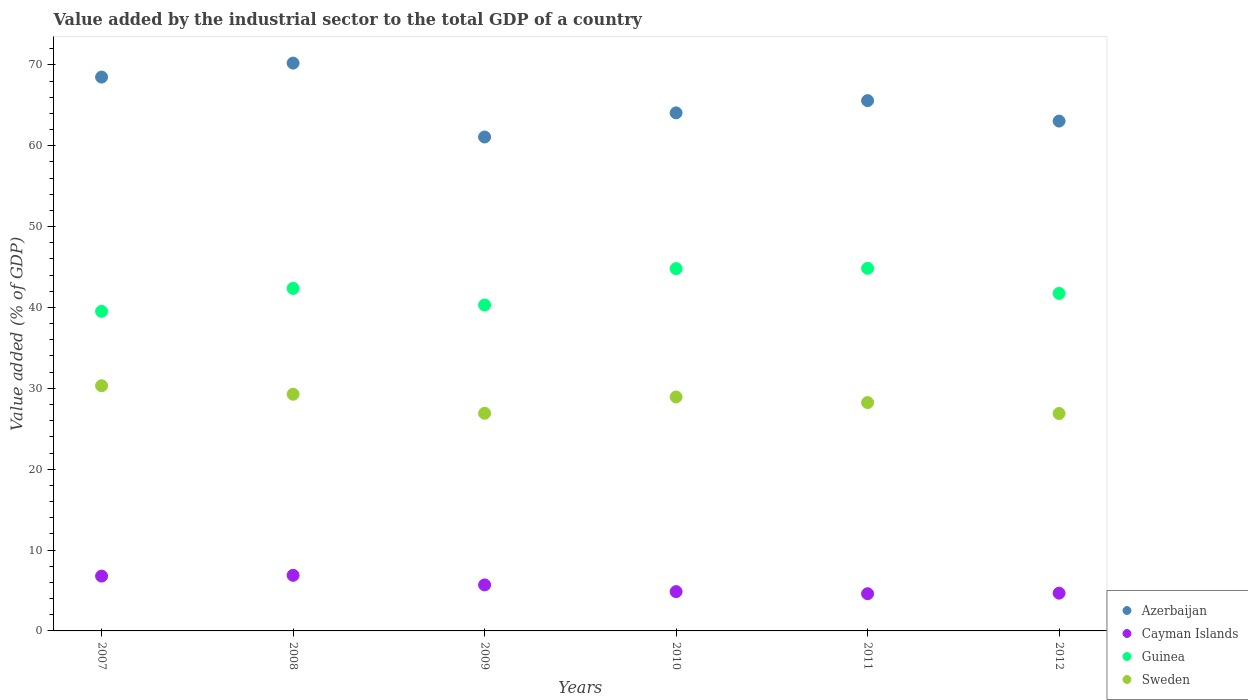How many different coloured dotlines are there?
Offer a terse response. 4. Is the number of dotlines equal to the number of legend labels?
Keep it short and to the point. Yes. What is the value added by the industrial sector to the total GDP in Azerbaijan in 2009?
Provide a succinct answer. 61.08. Across all years, what is the maximum value added by the industrial sector to the total GDP in Sweden?
Your response must be concise. 30.32. Across all years, what is the minimum value added by the industrial sector to the total GDP in Azerbaijan?
Give a very brief answer. 61.08. In which year was the value added by the industrial sector to the total GDP in Guinea minimum?
Give a very brief answer. 2007. What is the total value added by the industrial sector to the total GDP in Guinea in the graph?
Offer a very short reply. 253.57. What is the difference between the value added by the industrial sector to the total GDP in Sweden in 2009 and that in 2012?
Your answer should be very brief. 0.03. What is the difference between the value added by the industrial sector to the total GDP in Guinea in 2011 and the value added by the industrial sector to the total GDP in Cayman Islands in 2012?
Provide a short and direct response. 40.17. What is the average value added by the industrial sector to the total GDP in Azerbaijan per year?
Provide a short and direct response. 65.42. In the year 2008, what is the difference between the value added by the industrial sector to the total GDP in Cayman Islands and value added by the industrial sector to the total GDP in Sweden?
Your response must be concise. -22.4. In how many years, is the value added by the industrial sector to the total GDP in Cayman Islands greater than 64 %?
Ensure brevity in your answer.  0. What is the ratio of the value added by the industrial sector to the total GDP in Cayman Islands in 2008 to that in 2010?
Provide a short and direct response. 1.41. Is the value added by the industrial sector to the total GDP in Sweden in 2007 less than that in 2008?
Keep it short and to the point. No. Is the difference between the value added by the industrial sector to the total GDP in Cayman Islands in 2009 and 2010 greater than the difference between the value added by the industrial sector to the total GDP in Sweden in 2009 and 2010?
Provide a succinct answer. Yes. What is the difference between the highest and the second highest value added by the industrial sector to the total GDP in Sweden?
Give a very brief answer. 1.05. What is the difference between the highest and the lowest value added by the industrial sector to the total GDP in Azerbaijan?
Offer a terse response. 9.14. In how many years, is the value added by the industrial sector to the total GDP in Cayman Islands greater than the average value added by the industrial sector to the total GDP in Cayman Islands taken over all years?
Offer a very short reply. 3. Is the sum of the value added by the industrial sector to the total GDP in Guinea in 2007 and 2011 greater than the maximum value added by the industrial sector to the total GDP in Azerbaijan across all years?
Keep it short and to the point. Yes. Is it the case that in every year, the sum of the value added by the industrial sector to the total GDP in Azerbaijan and value added by the industrial sector to the total GDP in Cayman Islands  is greater than the sum of value added by the industrial sector to the total GDP in Sweden and value added by the industrial sector to the total GDP in Guinea?
Give a very brief answer. Yes. Does the value added by the industrial sector to the total GDP in Sweden monotonically increase over the years?
Your answer should be very brief. No. How many dotlines are there?
Provide a succinct answer. 4. How many years are there in the graph?
Your answer should be very brief. 6. What is the difference between two consecutive major ticks on the Y-axis?
Give a very brief answer. 10. Are the values on the major ticks of Y-axis written in scientific E-notation?
Make the answer very short. No. What is the title of the graph?
Your answer should be compact. Value added by the industrial sector to the total GDP of a country. What is the label or title of the X-axis?
Your response must be concise. Years. What is the label or title of the Y-axis?
Provide a short and direct response. Value added (% of GDP). What is the Value added (% of GDP) in Azerbaijan in 2007?
Offer a terse response. 68.49. What is the Value added (% of GDP) in Cayman Islands in 2007?
Keep it short and to the point. 6.78. What is the Value added (% of GDP) in Guinea in 2007?
Your answer should be very brief. 39.52. What is the Value added (% of GDP) in Sweden in 2007?
Give a very brief answer. 30.32. What is the Value added (% of GDP) in Azerbaijan in 2008?
Ensure brevity in your answer.  70.22. What is the Value added (% of GDP) in Cayman Islands in 2008?
Your answer should be compact. 6.87. What is the Value added (% of GDP) of Guinea in 2008?
Your answer should be very brief. 42.36. What is the Value added (% of GDP) of Sweden in 2008?
Ensure brevity in your answer.  29.27. What is the Value added (% of GDP) in Azerbaijan in 2009?
Ensure brevity in your answer.  61.08. What is the Value added (% of GDP) of Cayman Islands in 2009?
Provide a succinct answer. 5.69. What is the Value added (% of GDP) in Guinea in 2009?
Offer a very short reply. 40.31. What is the Value added (% of GDP) in Sweden in 2009?
Keep it short and to the point. 26.92. What is the Value added (% of GDP) in Azerbaijan in 2010?
Offer a terse response. 64.07. What is the Value added (% of GDP) in Cayman Islands in 2010?
Keep it short and to the point. 4.86. What is the Value added (% of GDP) of Guinea in 2010?
Offer a terse response. 44.8. What is the Value added (% of GDP) in Sweden in 2010?
Give a very brief answer. 28.93. What is the Value added (% of GDP) in Azerbaijan in 2011?
Make the answer very short. 65.58. What is the Value added (% of GDP) of Cayman Islands in 2011?
Your answer should be very brief. 4.6. What is the Value added (% of GDP) in Guinea in 2011?
Your answer should be compact. 44.84. What is the Value added (% of GDP) in Sweden in 2011?
Provide a succinct answer. 28.24. What is the Value added (% of GDP) in Azerbaijan in 2012?
Ensure brevity in your answer.  63.05. What is the Value added (% of GDP) of Cayman Islands in 2012?
Give a very brief answer. 4.67. What is the Value added (% of GDP) in Guinea in 2012?
Give a very brief answer. 41.74. What is the Value added (% of GDP) of Sweden in 2012?
Make the answer very short. 26.89. Across all years, what is the maximum Value added (% of GDP) in Azerbaijan?
Give a very brief answer. 70.22. Across all years, what is the maximum Value added (% of GDP) in Cayman Islands?
Make the answer very short. 6.87. Across all years, what is the maximum Value added (% of GDP) of Guinea?
Offer a very short reply. 44.84. Across all years, what is the maximum Value added (% of GDP) of Sweden?
Keep it short and to the point. 30.32. Across all years, what is the minimum Value added (% of GDP) of Azerbaijan?
Your answer should be compact. 61.08. Across all years, what is the minimum Value added (% of GDP) in Cayman Islands?
Your response must be concise. 4.6. Across all years, what is the minimum Value added (% of GDP) of Guinea?
Ensure brevity in your answer.  39.52. Across all years, what is the minimum Value added (% of GDP) of Sweden?
Give a very brief answer. 26.89. What is the total Value added (% of GDP) of Azerbaijan in the graph?
Make the answer very short. 392.5. What is the total Value added (% of GDP) of Cayman Islands in the graph?
Your response must be concise. 33.47. What is the total Value added (% of GDP) of Guinea in the graph?
Your answer should be compact. 253.57. What is the total Value added (% of GDP) in Sweden in the graph?
Provide a short and direct response. 170.56. What is the difference between the Value added (% of GDP) of Azerbaijan in 2007 and that in 2008?
Your answer should be very brief. -1.73. What is the difference between the Value added (% of GDP) of Cayman Islands in 2007 and that in 2008?
Provide a short and direct response. -0.09. What is the difference between the Value added (% of GDP) in Guinea in 2007 and that in 2008?
Keep it short and to the point. -2.84. What is the difference between the Value added (% of GDP) of Sweden in 2007 and that in 2008?
Keep it short and to the point. 1.05. What is the difference between the Value added (% of GDP) of Azerbaijan in 2007 and that in 2009?
Offer a very short reply. 7.41. What is the difference between the Value added (% of GDP) of Cayman Islands in 2007 and that in 2009?
Your answer should be very brief. 1.09. What is the difference between the Value added (% of GDP) of Guinea in 2007 and that in 2009?
Give a very brief answer. -0.78. What is the difference between the Value added (% of GDP) in Sweden in 2007 and that in 2009?
Your answer should be very brief. 3.4. What is the difference between the Value added (% of GDP) in Azerbaijan in 2007 and that in 2010?
Your answer should be very brief. 4.43. What is the difference between the Value added (% of GDP) of Cayman Islands in 2007 and that in 2010?
Give a very brief answer. 1.92. What is the difference between the Value added (% of GDP) of Guinea in 2007 and that in 2010?
Ensure brevity in your answer.  -5.28. What is the difference between the Value added (% of GDP) of Sweden in 2007 and that in 2010?
Provide a short and direct response. 1.39. What is the difference between the Value added (% of GDP) in Azerbaijan in 2007 and that in 2011?
Ensure brevity in your answer.  2.91. What is the difference between the Value added (% of GDP) of Cayman Islands in 2007 and that in 2011?
Ensure brevity in your answer.  2.18. What is the difference between the Value added (% of GDP) in Guinea in 2007 and that in 2011?
Ensure brevity in your answer.  -5.32. What is the difference between the Value added (% of GDP) in Sweden in 2007 and that in 2011?
Keep it short and to the point. 2.08. What is the difference between the Value added (% of GDP) of Azerbaijan in 2007 and that in 2012?
Offer a terse response. 5.44. What is the difference between the Value added (% of GDP) of Cayman Islands in 2007 and that in 2012?
Your response must be concise. 2.11. What is the difference between the Value added (% of GDP) in Guinea in 2007 and that in 2012?
Provide a succinct answer. -2.22. What is the difference between the Value added (% of GDP) in Sweden in 2007 and that in 2012?
Offer a very short reply. 3.43. What is the difference between the Value added (% of GDP) of Azerbaijan in 2008 and that in 2009?
Offer a very short reply. 9.14. What is the difference between the Value added (% of GDP) in Cayman Islands in 2008 and that in 2009?
Give a very brief answer. 1.18. What is the difference between the Value added (% of GDP) in Guinea in 2008 and that in 2009?
Give a very brief answer. 2.05. What is the difference between the Value added (% of GDP) of Sweden in 2008 and that in 2009?
Provide a short and direct response. 2.35. What is the difference between the Value added (% of GDP) in Azerbaijan in 2008 and that in 2010?
Provide a short and direct response. 6.15. What is the difference between the Value added (% of GDP) in Cayman Islands in 2008 and that in 2010?
Your answer should be compact. 2.01. What is the difference between the Value added (% of GDP) of Guinea in 2008 and that in 2010?
Offer a very short reply. -2.44. What is the difference between the Value added (% of GDP) in Sweden in 2008 and that in 2010?
Give a very brief answer. 0.34. What is the difference between the Value added (% of GDP) of Azerbaijan in 2008 and that in 2011?
Give a very brief answer. 4.64. What is the difference between the Value added (% of GDP) of Cayman Islands in 2008 and that in 2011?
Make the answer very short. 2.27. What is the difference between the Value added (% of GDP) in Guinea in 2008 and that in 2011?
Provide a short and direct response. -2.48. What is the difference between the Value added (% of GDP) of Sweden in 2008 and that in 2011?
Provide a short and direct response. 1.03. What is the difference between the Value added (% of GDP) of Azerbaijan in 2008 and that in 2012?
Keep it short and to the point. 7.17. What is the difference between the Value added (% of GDP) in Cayman Islands in 2008 and that in 2012?
Offer a terse response. 2.2. What is the difference between the Value added (% of GDP) of Guinea in 2008 and that in 2012?
Offer a very short reply. 0.62. What is the difference between the Value added (% of GDP) of Sweden in 2008 and that in 2012?
Offer a very short reply. 2.38. What is the difference between the Value added (% of GDP) of Azerbaijan in 2009 and that in 2010?
Your answer should be compact. -2.98. What is the difference between the Value added (% of GDP) in Cayman Islands in 2009 and that in 2010?
Your answer should be compact. 0.83. What is the difference between the Value added (% of GDP) in Guinea in 2009 and that in 2010?
Offer a terse response. -4.5. What is the difference between the Value added (% of GDP) of Sweden in 2009 and that in 2010?
Your response must be concise. -2.01. What is the difference between the Value added (% of GDP) of Azerbaijan in 2009 and that in 2011?
Your response must be concise. -4.5. What is the difference between the Value added (% of GDP) in Cayman Islands in 2009 and that in 2011?
Your answer should be compact. 1.09. What is the difference between the Value added (% of GDP) of Guinea in 2009 and that in 2011?
Provide a succinct answer. -4.54. What is the difference between the Value added (% of GDP) in Sweden in 2009 and that in 2011?
Keep it short and to the point. -1.32. What is the difference between the Value added (% of GDP) of Azerbaijan in 2009 and that in 2012?
Your answer should be very brief. -1.97. What is the difference between the Value added (% of GDP) in Cayman Islands in 2009 and that in 2012?
Provide a short and direct response. 1.02. What is the difference between the Value added (% of GDP) of Guinea in 2009 and that in 2012?
Ensure brevity in your answer.  -1.44. What is the difference between the Value added (% of GDP) in Sweden in 2009 and that in 2012?
Keep it short and to the point. 0.03. What is the difference between the Value added (% of GDP) of Azerbaijan in 2010 and that in 2011?
Keep it short and to the point. -1.51. What is the difference between the Value added (% of GDP) of Cayman Islands in 2010 and that in 2011?
Your answer should be very brief. 0.26. What is the difference between the Value added (% of GDP) in Guinea in 2010 and that in 2011?
Provide a short and direct response. -0.04. What is the difference between the Value added (% of GDP) of Sweden in 2010 and that in 2011?
Your response must be concise. 0.69. What is the difference between the Value added (% of GDP) of Azerbaijan in 2010 and that in 2012?
Ensure brevity in your answer.  1.02. What is the difference between the Value added (% of GDP) of Cayman Islands in 2010 and that in 2012?
Your answer should be compact. 0.19. What is the difference between the Value added (% of GDP) of Guinea in 2010 and that in 2012?
Your response must be concise. 3.06. What is the difference between the Value added (% of GDP) in Sweden in 2010 and that in 2012?
Offer a very short reply. 2.04. What is the difference between the Value added (% of GDP) in Azerbaijan in 2011 and that in 2012?
Your response must be concise. 2.53. What is the difference between the Value added (% of GDP) in Cayman Islands in 2011 and that in 2012?
Provide a short and direct response. -0.07. What is the difference between the Value added (% of GDP) in Guinea in 2011 and that in 2012?
Make the answer very short. 3.1. What is the difference between the Value added (% of GDP) of Sweden in 2011 and that in 2012?
Give a very brief answer. 1.35. What is the difference between the Value added (% of GDP) of Azerbaijan in 2007 and the Value added (% of GDP) of Cayman Islands in 2008?
Offer a very short reply. 61.62. What is the difference between the Value added (% of GDP) of Azerbaijan in 2007 and the Value added (% of GDP) of Guinea in 2008?
Make the answer very short. 26.14. What is the difference between the Value added (% of GDP) in Azerbaijan in 2007 and the Value added (% of GDP) in Sweden in 2008?
Your answer should be compact. 39.22. What is the difference between the Value added (% of GDP) of Cayman Islands in 2007 and the Value added (% of GDP) of Guinea in 2008?
Your answer should be very brief. -35.58. What is the difference between the Value added (% of GDP) in Cayman Islands in 2007 and the Value added (% of GDP) in Sweden in 2008?
Give a very brief answer. -22.49. What is the difference between the Value added (% of GDP) in Guinea in 2007 and the Value added (% of GDP) in Sweden in 2008?
Provide a succinct answer. 10.25. What is the difference between the Value added (% of GDP) in Azerbaijan in 2007 and the Value added (% of GDP) in Cayman Islands in 2009?
Keep it short and to the point. 62.8. What is the difference between the Value added (% of GDP) of Azerbaijan in 2007 and the Value added (% of GDP) of Guinea in 2009?
Ensure brevity in your answer.  28.19. What is the difference between the Value added (% of GDP) of Azerbaijan in 2007 and the Value added (% of GDP) of Sweden in 2009?
Provide a succinct answer. 41.58. What is the difference between the Value added (% of GDP) in Cayman Islands in 2007 and the Value added (% of GDP) in Guinea in 2009?
Ensure brevity in your answer.  -33.53. What is the difference between the Value added (% of GDP) of Cayman Islands in 2007 and the Value added (% of GDP) of Sweden in 2009?
Give a very brief answer. -20.14. What is the difference between the Value added (% of GDP) of Guinea in 2007 and the Value added (% of GDP) of Sweden in 2009?
Provide a short and direct response. 12.61. What is the difference between the Value added (% of GDP) of Azerbaijan in 2007 and the Value added (% of GDP) of Cayman Islands in 2010?
Offer a very short reply. 63.63. What is the difference between the Value added (% of GDP) in Azerbaijan in 2007 and the Value added (% of GDP) in Guinea in 2010?
Your answer should be compact. 23.69. What is the difference between the Value added (% of GDP) in Azerbaijan in 2007 and the Value added (% of GDP) in Sweden in 2010?
Offer a terse response. 39.56. What is the difference between the Value added (% of GDP) of Cayman Islands in 2007 and the Value added (% of GDP) of Guinea in 2010?
Provide a succinct answer. -38.02. What is the difference between the Value added (% of GDP) in Cayman Islands in 2007 and the Value added (% of GDP) in Sweden in 2010?
Offer a very short reply. -22.15. What is the difference between the Value added (% of GDP) of Guinea in 2007 and the Value added (% of GDP) of Sweden in 2010?
Offer a very short reply. 10.59. What is the difference between the Value added (% of GDP) in Azerbaijan in 2007 and the Value added (% of GDP) in Cayman Islands in 2011?
Your response must be concise. 63.9. What is the difference between the Value added (% of GDP) of Azerbaijan in 2007 and the Value added (% of GDP) of Guinea in 2011?
Give a very brief answer. 23.65. What is the difference between the Value added (% of GDP) in Azerbaijan in 2007 and the Value added (% of GDP) in Sweden in 2011?
Keep it short and to the point. 40.25. What is the difference between the Value added (% of GDP) of Cayman Islands in 2007 and the Value added (% of GDP) of Guinea in 2011?
Provide a short and direct response. -38.06. What is the difference between the Value added (% of GDP) in Cayman Islands in 2007 and the Value added (% of GDP) in Sweden in 2011?
Your answer should be very brief. -21.46. What is the difference between the Value added (% of GDP) in Guinea in 2007 and the Value added (% of GDP) in Sweden in 2011?
Give a very brief answer. 11.28. What is the difference between the Value added (% of GDP) in Azerbaijan in 2007 and the Value added (% of GDP) in Cayman Islands in 2012?
Your answer should be compact. 63.82. What is the difference between the Value added (% of GDP) of Azerbaijan in 2007 and the Value added (% of GDP) of Guinea in 2012?
Provide a short and direct response. 26.75. What is the difference between the Value added (% of GDP) of Azerbaijan in 2007 and the Value added (% of GDP) of Sweden in 2012?
Keep it short and to the point. 41.61. What is the difference between the Value added (% of GDP) of Cayman Islands in 2007 and the Value added (% of GDP) of Guinea in 2012?
Your answer should be very brief. -34.96. What is the difference between the Value added (% of GDP) of Cayman Islands in 2007 and the Value added (% of GDP) of Sweden in 2012?
Provide a short and direct response. -20.11. What is the difference between the Value added (% of GDP) in Guinea in 2007 and the Value added (% of GDP) in Sweden in 2012?
Give a very brief answer. 12.64. What is the difference between the Value added (% of GDP) in Azerbaijan in 2008 and the Value added (% of GDP) in Cayman Islands in 2009?
Offer a terse response. 64.53. What is the difference between the Value added (% of GDP) of Azerbaijan in 2008 and the Value added (% of GDP) of Guinea in 2009?
Your response must be concise. 29.92. What is the difference between the Value added (% of GDP) in Azerbaijan in 2008 and the Value added (% of GDP) in Sweden in 2009?
Give a very brief answer. 43.31. What is the difference between the Value added (% of GDP) in Cayman Islands in 2008 and the Value added (% of GDP) in Guinea in 2009?
Offer a very short reply. -33.43. What is the difference between the Value added (% of GDP) in Cayman Islands in 2008 and the Value added (% of GDP) in Sweden in 2009?
Provide a succinct answer. -20.04. What is the difference between the Value added (% of GDP) of Guinea in 2008 and the Value added (% of GDP) of Sweden in 2009?
Provide a succinct answer. 15.44. What is the difference between the Value added (% of GDP) in Azerbaijan in 2008 and the Value added (% of GDP) in Cayman Islands in 2010?
Give a very brief answer. 65.36. What is the difference between the Value added (% of GDP) in Azerbaijan in 2008 and the Value added (% of GDP) in Guinea in 2010?
Provide a short and direct response. 25.42. What is the difference between the Value added (% of GDP) in Azerbaijan in 2008 and the Value added (% of GDP) in Sweden in 2010?
Your response must be concise. 41.29. What is the difference between the Value added (% of GDP) of Cayman Islands in 2008 and the Value added (% of GDP) of Guinea in 2010?
Your answer should be compact. -37.93. What is the difference between the Value added (% of GDP) in Cayman Islands in 2008 and the Value added (% of GDP) in Sweden in 2010?
Your answer should be very brief. -22.06. What is the difference between the Value added (% of GDP) in Guinea in 2008 and the Value added (% of GDP) in Sweden in 2010?
Your answer should be very brief. 13.43. What is the difference between the Value added (% of GDP) in Azerbaijan in 2008 and the Value added (% of GDP) in Cayman Islands in 2011?
Provide a succinct answer. 65.62. What is the difference between the Value added (% of GDP) in Azerbaijan in 2008 and the Value added (% of GDP) in Guinea in 2011?
Your answer should be compact. 25.38. What is the difference between the Value added (% of GDP) of Azerbaijan in 2008 and the Value added (% of GDP) of Sweden in 2011?
Offer a terse response. 41.98. What is the difference between the Value added (% of GDP) of Cayman Islands in 2008 and the Value added (% of GDP) of Guinea in 2011?
Provide a short and direct response. -37.97. What is the difference between the Value added (% of GDP) of Cayman Islands in 2008 and the Value added (% of GDP) of Sweden in 2011?
Keep it short and to the point. -21.37. What is the difference between the Value added (% of GDP) of Guinea in 2008 and the Value added (% of GDP) of Sweden in 2011?
Keep it short and to the point. 14.12. What is the difference between the Value added (% of GDP) in Azerbaijan in 2008 and the Value added (% of GDP) in Cayman Islands in 2012?
Keep it short and to the point. 65.55. What is the difference between the Value added (% of GDP) of Azerbaijan in 2008 and the Value added (% of GDP) of Guinea in 2012?
Offer a very short reply. 28.48. What is the difference between the Value added (% of GDP) of Azerbaijan in 2008 and the Value added (% of GDP) of Sweden in 2012?
Provide a short and direct response. 43.33. What is the difference between the Value added (% of GDP) in Cayman Islands in 2008 and the Value added (% of GDP) in Guinea in 2012?
Offer a very short reply. -34.87. What is the difference between the Value added (% of GDP) in Cayman Islands in 2008 and the Value added (% of GDP) in Sweden in 2012?
Your answer should be very brief. -20.01. What is the difference between the Value added (% of GDP) in Guinea in 2008 and the Value added (% of GDP) in Sweden in 2012?
Offer a very short reply. 15.47. What is the difference between the Value added (% of GDP) of Azerbaijan in 2009 and the Value added (% of GDP) of Cayman Islands in 2010?
Give a very brief answer. 56.22. What is the difference between the Value added (% of GDP) in Azerbaijan in 2009 and the Value added (% of GDP) in Guinea in 2010?
Your answer should be very brief. 16.28. What is the difference between the Value added (% of GDP) of Azerbaijan in 2009 and the Value added (% of GDP) of Sweden in 2010?
Provide a short and direct response. 32.15. What is the difference between the Value added (% of GDP) in Cayman Islands in 2009 and the Value added (% of GDP) in Guinea in 2010?
Your answer should be compact. -39.11. What is the difference between the Value added (% of GDP) in Cayman Islands in 2009 and the Value added (% of GDP) in Sweden in 2010?
Offer a terse response. -23.24. What is the difference between the Value added (% of GDP) of Guinea in 2009 and the Value added (% of GDP) of Sweden in 2010?
Give a very brief answer. 11.37. What is the difference between the Value added (% of GDP) in Azerbaijan in 2009 and the Value added (% of GDP) in Cayman Islands in 2011?
Keep it short and to the point. 56.48. What is the difference between the Value added (% of GDP) of Azerbaijan in 2009 and the Value added (% of GDP) of Guinea in 2011?
Ensure brevity in your answer.  16.24. What is the difference between the Value added (% of GDP) in Azerbaijan in 2009 and the Value added (% of GDP) in Sweden in 2011?
Your answer should be compact. 32.84. What is the difference between the Value added (% of GDP) in Cayman Islands in 2009 and the Value added (% of GDP) in Guinea in 2011?
Give a very brief answer. -39.15. What is the difference between the Value added (% of GDP) of Cayman Islands in 2009 and the Value added (% of GDP) of Sweden in 2011?
Offer a very short reply. -22.55. What is the difference between the Value added (% of GDP) in Guinea in 2009 and the Value added (% of GDP) in Sweden in 2011?
Ensure brevity in your answer.  12.07. What is the difference between the Value added (% of GDP) of Azerbaijan in 2009 and the Value added (% of GDP) of Cayman Islands in 2012?
Offer a very short reply. 56.41. What is the difference between the Value added (% of GDP) in Azerbaijan in 2009 and the Value added (% of GDP) in Guinea in 2012?
Offer a terse response. 19.34. What is the difference between the Value added (% of GDP) of Azerbaijan in 2009 and the Value added (% of GDP) of Sweden in 2012?
Make the answer very short. 34.2. What is the difference between the Value added (% of GDP) of Cayman Islands in 2009 and the Value added (% of GDP) of Guinea in 2012?
Provide a short and direct response. -36.05. What is the difference between the Value added (% of GDP) of Cayman Islands in 2009 and the Value added (% of GDP) of Sweden in 2012?
Provide a succinct answer. -21.2. What is the difference between the Value added (% of GDP) of Guinea in 2009 and the Value added (% of GDP) of Sweden in 2012?
Provide a succinct answer. 13.42. What is the difference between the Value added (% of GDP) in Azerbaijan in 2010 and the Value added (% of GDP) in Cayman Islands in 2011?
Your answer should be compact. 59.47. What is the difference between the Value added (% of GDP) of Azerbaijan in 2010 and the Value added (% of GDP) of Guinea in 2011?
Offer a terse response. 19.23. What is the difference between the Value added (% of GDP) in Azerbaijan in 2010 and the Value added (% of GDP) in Sweden in 2011?
Offer a terse response. 35.83. What is the difference between the Value added (% of GDP) of Cayman Islands in 2010 and the Value added (% of GDP) of Guinea in 2011?
Give a very brief answer. -39.98. What is the difference between the Value added (% of GDP) in Cayman Islands in 2010 and the Value added (% of GDP) in Sweden in 2011?
Provide a short and direct response. -23.38. What is the difference between the Value added (% of GDP) in Guinea in 2010 and the Value added (% of GDP) in Sweden in 2011?
Ensure brevity in your answer.  16.56. What is the difference between the Value added (% of GDP) of Azerbaijan in 2010 and the Value added (% of GDP) of Cayman Islands in 2012?
Your answer should be very brief. 59.4. What is the difference between the Value added (% of GDP) of Azerbaijan in 2010 and the Value added (% of GDP) of Guinea in 2012?
Ensure brevity in your answer.  22.33. What is the difference between the Value added (% of GDP) in Azerbaijan in 2010 and the Value added (% of GDP) in Sweden in 2012?
Provide a succinct answer. 37.18. What is the difference between the Value added (% of GDP) of Cayman Islands in 2010 and the Value added (% of GDP) of Guinea in 2012?
Your answer should be very brief. -36.88. What is the difference between the Value added (% of GDP) in Cayman Islands in 2010 and the Value added (% of GDP) in Sweden in 2012?
Your response must be concise. -22.03. What is the difference between the Value added (% of GDP) in Guinea in 2010 and the Value added (% of GDP) in Sweden in 2012?
Offer a terse response. 17.91. What is the difference between the Value added (% of GDP) of Azerbaijan in 2011 and the Value added (% of GDP) of Cayman Islands in 2012?
Give a very brief answer. 60.91. What is the difference between the Value added (% of GDP) of Azerbaijan in 2011 and the Value added (% of GDP) of Guinea in 2012?
Keep it short and to the point. 23.84. What is the difference between the Value added (% of GDP) in Azerbaijan in 2011 and the Value added (% of GDP) in Sweden in 2012?
Offer a terse response. 38.69. What is the difference between the Value added (% of GDP) of Cayman Islands in 2011 and the Value added (% of GDP) of Guinea in 2012?
Offer a very short reply. -37.14. What is the difference between the Value added (% of GDP) in Cayman Islands in 2011 and the Value added (% of GDP) in Sweden in 2012?
Offer a terse response. -22.29. What is the difference between the Value added (% of GDP) in Guinea in 2011 and the Value added (% of GDP) in Sweden in 2012?
Your response must be concise. 17.95. What is the average Value added (% of GDP) in Azerbaijan per year?
Ensure brevity in your answer.  65.42. What is the average Value added (% of GDP) of Cayman Islands per year?
Give a very brief answer. 5.58. What is the average Value added (% of GDP) of Guinea per year?
Provide a succinct answer. 42.26. What is the average Value added (% of GDP) of Sweden per year?
Provide a short and direct response. 28.43. In the year 2007, what is the difference between the Value added (% of GDP) of Azerbaijan and Value added (% of GDP) of Cayman Islands?
Keep it short and to the point. 61.71. In the year 2007, what is the difference between the Value added (% of GDP) in Azerbaijan and Value added (% of GDP) in Guinea?
Offer a terse response. 28.97. In the year 2007, what is the difference between the Value added (% of GDP) in Azerbaijan and Value added (% of GDP) in Sweden?
Ensure brevity in your answer.  38.18. In the year 2007, what is the difference between the Value added (% of GDP) of Cayman Islands and Value added (% of GDP) of Guinea?
Ensure brevity in your answer.  -32.74. In the year 2007, what is the difference between the Value added (% of GDP) of Cayman Islands and Value added (% of GDP) of Sweden?
Offer a terse response. -23.54. In the year 2007, what is the difference between the Value added (% of GDP) of Guinea and Value added (% of GDP) of Sweden?
Ensure brevity in your answer.  9.2. In the year 2008, what is the difference between the Value added (% of GDP) of Azerbaijan and Value added (% of GDP) of Cayman Islands?
Ensure brevity in your answer.  63.35. In the year 2008, what is the difference between the Value added (% of GDP) of Azerbaijan and Value added (% of GDP) of Guinea?
Provide a succinct answer. 27.86. In the year 2008, what is the difference between the Value added (% of GDP) in Azerbaijan and Value added (% of GDP) in Sweden?
Offer a very short reply. 40.95. In the year 2008, what is the difference between the Value added (% of GDP) in Cayman Islands and Value added (% of GDP) in Guinea?
Offer a terse response. -35.48. In the year 2008, what is the difference between the Value added (% of GDP) in Cayman Islands and Value added (% of GDP) in Sweden?
Make the answer very short. -22.4. In the year 2008, what is the difference between the Value added (% of GDP) in Guinea and Value added (% of GDP) in Sweden?
Your response must be concise. 13.09. In the year 2009, what is the difference between the Value added (% of GDP) of Azerbaijan and Value added (% of GDP) of Cayman Islands?
Provide a succinct answer. 55.39. In the year 2009, what is the difference between the Value added (% of GDP) of Azerbaijan and Value added (% of GDP) of Guinea?
Give a very brief answer. 20.78. In the year 2009, what is the difference between the Value added (% of GDP) in Azerbaijan and Value added (% of GDP) in Sweden?
Keep it short and to the point. 34.17. In the year 2009, what is the difference between the Value added (% of GDP) in Cayman Islands and Value added (% of GDP) in Guinea?
Ensure brevity in your answer.  -34.62. In the year 2009, what is the difference between the Value added (% of GDP) in Cayman Islands and Value added (% of GDP) in Sweden?
Keep it short and to the point. -21.23. In the year 2009, what is the difference between the Value added (% of GDP) of Guinea and Value added (% of GDP) of Sweden?
Your answer should be compact. 13.39. In the year 2010, what is the difference between the Value added (% of GDP) in Azerbaijan and Value added (% of GDP) in Cayman Islands?
Give a very brief answer. 59.21. In the year 2010, what is the difference between the Value added (% of GDP) in Azerbaijan and Value added (% of GDP) in Guinea?
Ensure brevity in your answer.  19.26. In the year 2010, what is the difference between the Value added (% of GDP) in Azerbaijan and Value added (% of GDP) in Sweden?
Keep it short and to the point. 35.14. In the year 2010, what is the difference between the Value added (% of GDP) in Cayman Islands and Value added (% of GDP) in Guinea?
Give a very brief answer. -39.94. In the year 2010, what is the difference between the Value added (% of GDP) in Cayman Islands and Value added (% of GDP) in Sweden?
Your response must be concise. -24.07. In the year 2010, what is the difference between the Value added (% of GDP) in Guinea and Value added (% of GDP) in Sweden?
Make the answer very short. 15.87. In the year 2011, what is the difference between the Value added (% of GDP) in Azerbaijan and Value added (% of GDP) in Cayman Islands?
Provide a short and direct response. 60.98. In the year 2011, what is the difference between the Value added (% of GDP) in Azerbaijan and Value added (% of GDP) in Guinea?
Offer a terse response. 20.74. In the year 2011, what is the difference between the Value added (% of GDP) in Azerbaijan and Value added (% of GDP) in Sweden?
Make the answer very short. 37.34. In the year 2011, what is the difference between the Value added (% of GDP) in Cayman Islands and Value added (% of GDP) in Guinea?
Your answer should be very brief. -40.24. In the year 2011, what is the difference between the Value added (% of GDP) in Cayman Islands and Value added (% of GDP) in Sweden?
Keep it short and to the point. -23.64. In the year 2011, what is the difference between the Value added (% of GDP) in Guinea and Value added (% of GDP) in Sweden?
Provide a succinct answer. 16.6. In the year 2012, what is the difference between the Value added (% of GDP) in Azerbaijan and Value added (% of GDP) in Cayman Islands?
Give a very brief answer. 58.38. In the year 2012, what is the difference between the Value added (% of GDP) in Azerbaijan and Value added (% of GDP) in Guinea?
Make the answer very short. 21.31. In the year 2012, what is the difference between the Value added (% of GDP) in Azerbaijan and Value added (% of GDP) in Sweden?
Your answer should be compact. 36.16. In the year 2012, what is the difference between the Value added (% of GDP) in Cayman Islands and Value added (% of GDP) in Guinea?
Give a very brief answer. -37.07. In the year 2012, what is the difference between the Value added (% of GDP) of Cayman Islands and Value added (% of GDP) of Sweden?
Provide a short and direct response. -22.22. In the year 2012, what is the difference between the Value added (% of GDP) in Guinea and Value added (% of GDP) in Sweden?
Ensure brevity in your answer.  14.85. What is the ratio of the Value added (% of GDP) of Azerbaijan in 2007 to that in 2008?
Provide a short and direct response. 0.98. What is the ratio of the Value added (% of GDP) of Cayman Islands in 2007 to that in 2008?
Provide a succinct answer. 0.99. What is the ratio of the Value added (% of GDP) of Guinea in 2007 to that in 2008?
Provide a succinct answer. 0.93. What is the ratio of the Value added (% of GDP) in Sweden in 2007 to that in 2008?
Your answer should be very brief. 1.04. What is the ratio of the Value added (% of GDP) of Azerbaijan in 2007 to that in 2009?
Ensure brevity in your answer.  1.12. What is the ratio of the Value added (% of GDP) of Cayman Islands in 2007 to that in 2009?
Provide a short and direct response. 1.19. What is the ratio of the Value added (% of GDP) in Guinea in 2007 to that in 2009?
Make the answer very short. 0.98. What is the ratio of the Value added (% of GDP) of Sweden in 2007 to that in 2009?
Your response must be concise. 1.13. What is the ratio of the Value added (% of GDP) in Azerbaijan in 2007 to that in 2010?
Provide a succinct answer. 1.07. What is the ratio of the Value added (% of GDP) of Cayman Islands in 2007 to that in 2010?
Give a very brief answer. 1.39. What is the ratio of the Value added (% of GDP) in Guinea in 2007 to that in 2010?
Provide a succinct answer. 0.88. What is the ratio of the Value added (% of GDP) of Sweden in 2007 to that in 2010?
Ensure brevity in your answer.  1.05. What is the ratio of the Value added (% of GDP) in Azerbaijan in 2007 to that in 2011?
Offer a terse response. 1.04. What is the ratio of the Value added (% of GDP) in Cayman Islands in 2007 to that in 2011?
Offer a very short reply. 1.47. What is the ratio of the Value added (% of GDP) of Guinea in 2007 to that in 2011?
Give a very brief answer. 0.88. What is the ratio of the Value added (% of GDP) in Sweden in 2007 to that in 2011?
Provide a succinct answer. 1.07. What is the ratio of the Value added (% of GDP) of Azerbaijan in 2007 to that in 2012?
Your response must be concise. 1.09. What is the ratio of the Value added (% of GDP) of Cayman Islands in 2007 to that in 2012?
Give a very brief answer. 1.45. What is the ratio of the Value added (% of GDP) in Guinea in 2007 to that in 2012?
Provide a short and direct response. 0.95. What is the ratio of the Value added (% of GDP) in Sweden in 2007 to that in 2012?
Ensure brevity in your answer.  1.13. What is the ratio of the Value added (% of GDP) in Azerbaijan in 2008 to that in 2009?
Make the answer very short. 1.15. What is the ratio of the Value added (% of GDP) of Cayman Islands in 2008 to that in 2009?
Provide a short and direct response. 1.21. What is the ratio of the Value added (% of GDP) in Guinea in 2008 to that in 2009?
Your answer should be very brief. 1.05. What is the ratio of the Value added (% of GDP) in Sweden in 2008 to that in 2009?
Give a very brief answer. 1.09. What is the ratio of the Value added (% of GDP) of Azerbaijan in 2008 to that in 2010?
Ensure brevity in your answer.  1.1. What is the ratio of the Value added (% of GDP) in Cayman Islands in 2008 to that in 2010?
Offer a very short reply. 1.41. What is the ratio of the Value added (% of GDP) of Guinea in 2008 to that in 2010?
Your answer should be compact. 0.95. What is the ratio of the Value added (% of GDP) of Sweden in 2008 to that in 2010?
Offer a very short reply. 1.01. What is the ratio of the Value added (% of GDP) in Azerbaijan in 2008 to that in 2011?
Ensure brevity in your answer.  1.07. What is the ratio of the Value added (% of GDP) in Cayman Islands in 2008 to that in 2011?
Make the answer very short. 1.49. What is the ratio of the Value added (% of GDP) in Guinea in 2008 to that in 2011?
Your answer should be very brief. 0.94. What is the ratio of the Value added (% of GDP) in Sweden in 2008 to that in 2011?
Offer a very short reply. 1.04. What is the ratio of the Value added (% of GDP) in Azerbaijan in 2008 to that in 2012?
Your answer should be very brief. 1.11. What is the ratio of the Value added (% of GDP) of Cayman Islands in 2008 to that in 2012?
Ensure brevity in your answer.  1.47. What is the ratio of the Value added (% of GDP) of Guinea in 2008 to that in 2012?
Make the answer very short. 1.01. What is the ratio of the Value added (% of GDP) of Sweden in 2008 to that in 2012?
Your answer should be compact. 1.09. What is the ratio of the Value added (% of GDP) in Azerbaijan in 2009 to that in 2010?
Your answer should be compact. 0.95. What is the ratio of the Value added (% of GDP) of Cayman Islands in 2009 to that in 2010?
Provide a short and direct response. 1.17. What is the ratio of the Value added (% of GDP) in Guinea in 2009 to that in 2010?
Your answer should be compact. 0.9. What is the ratio of the Value added (% of GDP) of Sweden in 2009 to that in 2010?
Provide a succinct answer. 0.93. What is the ratio of the Value added (% of GDP) in Azerbaijan in 2009 to that in 2011?
Give a very brief answer. 0.93. What is the ratio of the Value added (% of GDP) of Cayman Islands in 2009 to that in 2011?
Give a very brief answer. 1.24. What is the ratio of the Value added (% of GDP) in Guinea in 2009 to that in 2011?
Your answer should be very brief. 0.9. What is the ratio of the Value added (% of GDP) of Sweden in 2009 to that in 2011?
Keep it short and to the point. 0.95. What is the ratio of the Value added (% of GDP) in Azerbaijan in 2009 to that in 2012?
Give a very brief answer. 0.97. What is the ratio of the Value added (% of GDP) of Cayman Islands in 2009 to that in 2012?
Your answer should be very brief. 1.22. What is the ratio of the Value added (% of GDP) of Guinea in 2009 to that in 2012?
Ensure brevity in your answer.  0.97. What is the ratio of the Value added (% of GDP) of Sweden in 2009 to that in 2012?
Ensure brevity in your answer.  1. What is the ratio of the Value added (% of GDP) in Azerbaijan in 2010 to that in 2011?
Offer a terse response. 0.98. What is the ratio of the Value added (% of GDP) of Cayman Islands in 2010 to that in 2011?
Offer a terse response. 1.06. What is the ratio of the Value added (% of GDP) in Guinea in 2010 to that in 2011?
Offer a terse response. 1. What is the ratio of the Value added (% of GDP) of Sweden in 2010 to that in 2011?
Give a very brief answer. 1.02. What is the ratio of the Value added (% of GDP) of Azerbaijan in 2010 to that in 2012?
Ensure brevity in your answer.  1.02. What is the ratio of the Value added (% of GDP) in Cayman Islands in 2010 to that in 2012?
Offer a terse response. 1.04. What is the ratio of the Value added (% of GDP) of Guinea in 2010 to that in 2012?
Your answer should be very brief. 1.07. What is the ratio of the Value added (% of GDP) in Sweden in 2010 to that in 2012?
Provide a short and direct response. 1.08. What is the ratio of the Value added (% of GDP) of Azerbaijan in 2011 to that in 2012?
Your answer should be compact. 1.04. What is the ratio of the Value added (% of GDP) of Cayman Islands in 2011 to that in 2012?
Offer a very short reply. 0.98. What is the ratio of the Value added (% of GDP) in Guinea in 2011 to that in 2012?
Your response must be concise. 1.07. What is the ratio of the Value added (% of GDP) of Sweden in 2011 to that in 2012?
Your response must be concise. 1.05. What is the difference between the highest and the second highest Value added (% of GDP) of Azerbaijan?
Make the answer very short. 1.73. What is the difference between the highest and the second highest Value added (% of GDP) in Cayman Islands?
Make the answer very short. 0.09. What is the difference between the highest and the second highest Value added (% of GDP) in Guinea?
Give a very brief answer. 0.04. What is the difference between the highest and the second highest Value added (% of GDP) in Sweden?
Your response must be concise. 1.05. What is the difference between the highest and the lowest Value added (% of GDP) in Azerbaijan?
Provide a short and direct response. 9.14. What is the difference between the highest and the lowest Value added (% of GDP) of Cayman Islands?
Ensure brevity in your answer.  2.27. What is the difference between the highest and the lowest Value added (% of GDP) of Guinea?
Provide a succinct answer. 5.32. What is the difference between the highest and the lowest Value added (% of GDP) in Sweden?
Keep it short and to the point. 3.43. 